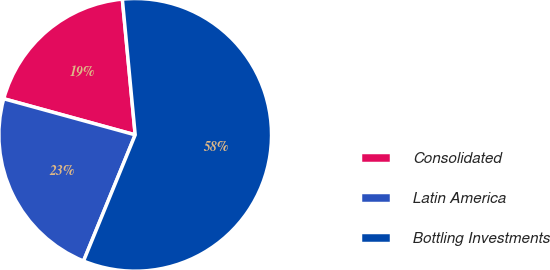Convert chart to OTSL. <chart><loc_0><loc_0><loc_500><loc_500><pie_chart><fcel>Consolidated<fcel>Latin America<fcel>Bottling Investments<nl><fcel>19.23%<fcel>23.08%<fcel>57.69%<nl></chart> 